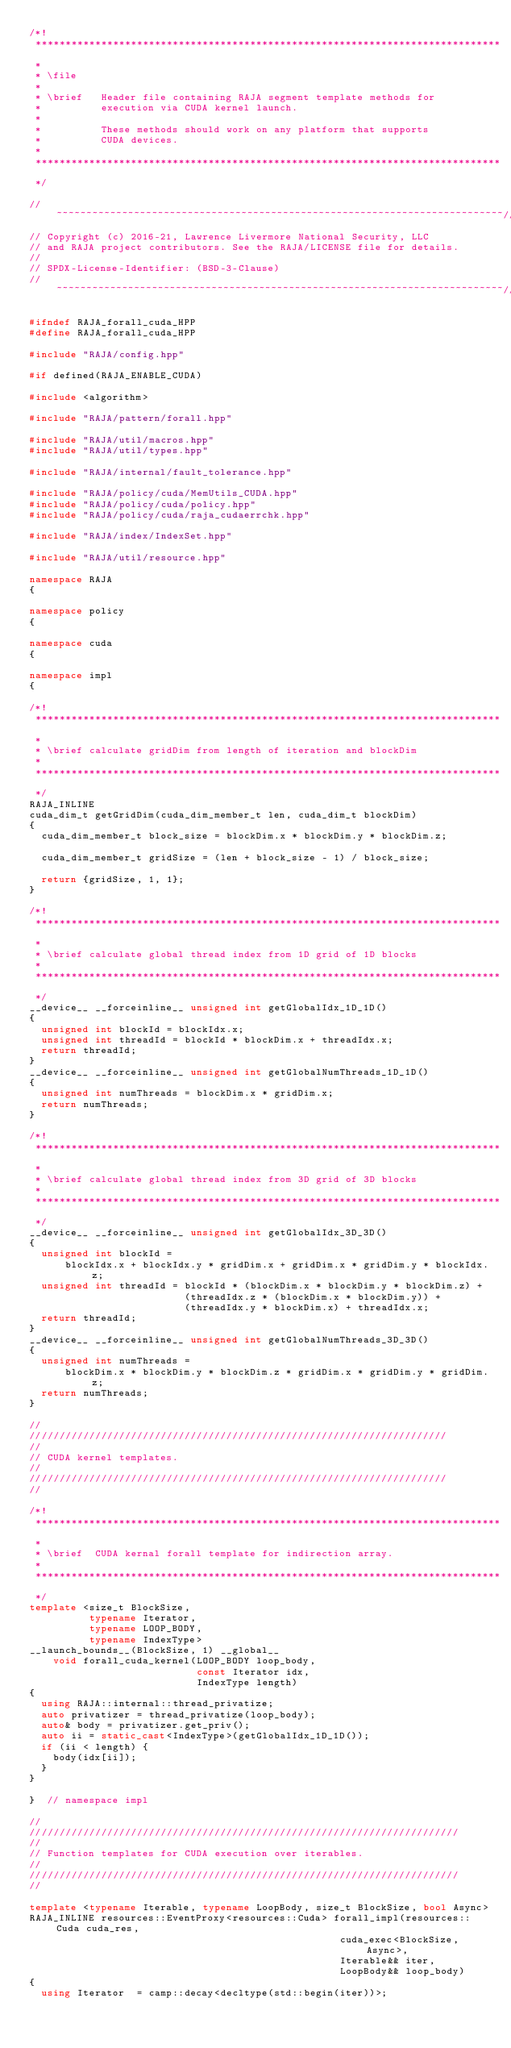<code> <loc_0><loc_0><loc_500><loc_500><_C++_>/*!
 ******************************************************************************
 *
 * \file
 *
 * \brief   Header file containing RAJA segment template methods for
 *          execution via CUDA kernel launch.
 *
 *          These methods should work on any platform that supports
 *          CUDA devices.
 *
 ******************************************************************************
 */

//~~~~~~~~~~~~~~~~~~~~~~~~~~~~~~~~~~~~~~~~~~~~~~~~~~~~~~~~~~~~~~~~~~~~~~~~~~~//
// Copyright (c) 2016-21, Lawrence Livermore National Security, LLC
// and RAJA project contributors. See the RAJA/LICENSE file for details.
//
// SPDX-License-Identifier: (BSD-3-Clause)
//~~~~~~~~~~~~~~~~~~~~~~~~~~~~~~~~~~~~~~~~~~~~~~~~~~~~~~~~~~~~~~~~~~~~~~~~~~~//

#ifndef RAJA_forall_cuda_HPP
#define RAJA_forall_cuda_HPP

#include "RAJA/config.hpp"

#if defined(RAJA_ENABLE_CUDA)

#include <algorithm>

#include "RAJA/pattern/forall.hpp"

#include "RAJA/util/macros.hpp"
#include "RAJA/util/types.hpp"

#include "RAJA/internal/fault_tolerance.hpp"

#include "RAJA/policy/cuda/MemUtils_CUDA.hpp"
#include "RAJA/policy/cuda/policy.hpp"
#include "RAJA/policy/cuda/raja_cudaerrchk.hpp"

#include "RAJA/index/IndexSet.hpp"

#include "RAJA/util/resource.hpp"

namespace RAJA
{

namespace policy
{

namespace cuda
{

namespace impl
{

/*!
 ******************************************************************************
 *
 * \brief calculate gridDim from length of iteration and blockDim
 *
 ******************************************************************************
 */
RAJA_INLINE
cuda_dim_t getGridDim(cuda_dim_member_t len, cuda_dim_t blockDim)
{
  cuda_dim_member_t block_size = blockDim.x * blockDim.y * blockDim.z;

  cuda_dim_member_t gridSize = (len + block_size - 1) / block_size;

  return {gridSize, 1, 1};
}

/*!
 ******************************************************************************
 *
 * \brief calculate global thread index from 1D grid of 1D blocks
 *
 ******************************************************************************
 */
__device__ __forceinline__ unsigned int getGlobalIdx_1D_1D()
{
  unsigned int blockId = blockIdx.x;
  unsigned int threadId = blockId * blockDim.x + threadIdx.x;
  return threadId;
}
__device__ __forceinline__ unsigned int getGlobalNumThreads_1D_1D()
{
  unsigned int numThreads = blockDim.x * gridDim.x;
  return numThreads;
}

/*!
 ******************************************************************************
 *
 * \brief calculate global thread index from 3D grid of 3D blocks
 *
 ******************************************************************************
 */
__device__ __forceinline__ unsigned int getGlobalIdx_3D_3D()
{
  unsigned int blockId =
      blockIdx.x + blockIdx.y * gridDim.x + gridDim.x * gridDim.y * blockIdx.z;
  unsigned int threadId = blockId * (blockDim.x * blockDim.y * blockDim.z) +
                          (threadIdx.z * (blockDim.x * blockDim.y)) +
                          (threadIdx.y * blockDim.x) + threadIdx.x;
  return threadId;
}
__device__ __forceinline__ unsigned int getGlobalNumThreads_3D_3D()
{
  unsigned int numThreads =
      blockDim.x * blockDim.y * blockDim.z * gridDim.x * gridDim.y * gridDim.z;
  return numThreads;
}

//
//////////////////////////////////////////////////////////////////////
//
// CUDA kernel templates.
//
//////////////////////////////////////////////////////////////////////
//

/*!
 ******************************************************************************
 *
 * \brief  CUDA kernal forall template for indirection array.
 *
 ******************************************************************************
 */
template <size_t BlockSize,
          typename Iterator,
          typename LOOP_BODY,
          typename IndexType>
__launch_bounds__(BlockSize, 1) __global__
    void forall_cuda_kernel(LOOP_BODY loop_body,
                            const Iterator idx,
                            IndexType length)
{
  using RAJA::internal::thread_privatize;
  auto privatizer = thread_privatize(loop_body);
  auto& body = privatizer.get_priv();
  auto ii = static_cast<IndexType>(getGlobalIdx_1D_1D());
  if (ii < length) {
    body(idx[ii]);
  }
}

}  // namespace impl

//
////////////////////////////////////////////////////////////////////////
//
// Function templates for CUDA execution over iterables.
//
////////////////////////////////////////////////////////////////////////
//

template <typename Iterable, typename LoopBody, size_t BlockSize, bool Async>
RAJA_INLINE resources::EventProxy<resources::Cuda> forall_impl(resources::Cuda cuda_res,
                                                    cuda_exec<BlockSize, Async>,
                                                    Iterable&& iter,
                                                    LoopBody&& loop_body)
{
  using Iterator  = camp::decay<decltype(std::begin(iter))>;</code> 